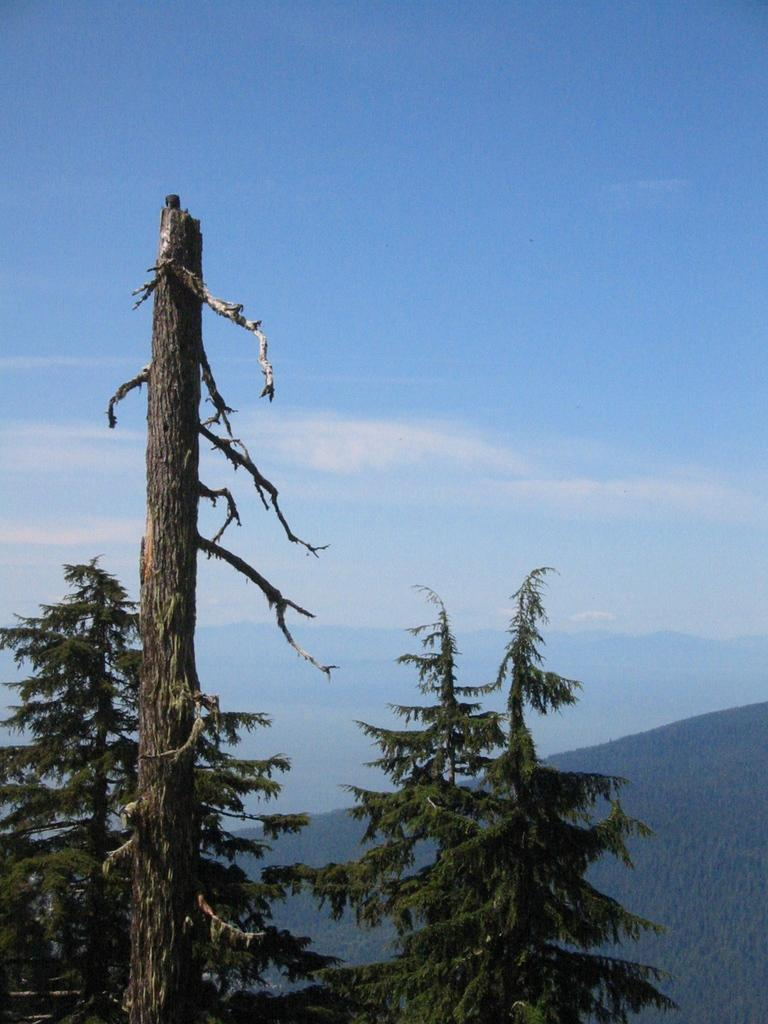What type of vegetation is in the foreground of the image? There are trees in the foreground of the image. What geographical feature is depicted in the image? The image appears to depict a mountain. What part of the natural environment is visible in the background of the image? The sky is visible in the background of the image. What type of marble can be seen on the mountain in the image? There is no marble present on the mountain in the image; it is a natural geographical feature. Can you hear the voice of the deer in the image? There are no deer present in the image, so it is not possible to hear their voice. 